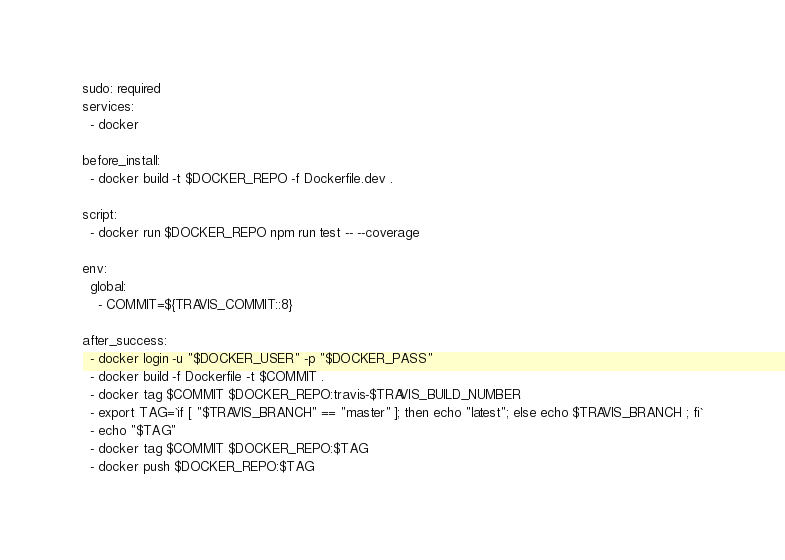<code> <loc_0><loc_0><loc_500><loc_500><_YAML_>sudo: required
services:
  - docker

before_install:
  - docker build -t $DOCKER_REPO -f Dockerfile.dev . 

script:
  - docker run $DOCKER_REPO npm run test -- --coverage

env:
  global:
    - COMMIT=${TRAVIS_COMMIT::8}

after_success:
  - docker login -u "$DOCKER_USER" -p "$DOCKER_PASS"
  - docker build -f Dockerfile -t $COMMIT .
  - docker tag $COMMIT $DOCKER_REPO:travis-$TRAVIS_BUILD_NUMBER
  - export TAG=`if [ "$TRAVIS_BRANCH" == "master" ]; then echo "latest"; else echo $TRAVIS_BRANCH ; fi`
  - echo "$TAG"
  - docker tag $COMMIT $DOCKER_REPO:$TAG
  - docker push $DOCKER_REPO:$TAG

</code> 